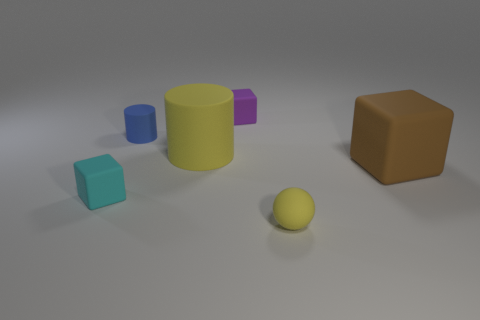Is the number of things that are to the left of the brown block greater than the number of tiny cyan metal balls?
Ensure brevity in your answer.  Yes. How many tiny things are either yellow matte cylinders or green rubber spheres?
Your response must be concise. 0. What number of big brown matte things are the same shape as the tiny yellow object?
Make the answer very short. 0. There is a cube to the right of the yellow matte sphere; what size is it?
Give a very brief answer. Large. What number of purple things are either tiny cylinders or spheres?
Provide a succinct answer. 0. What material is the other big thing that is the same shape as the blue matte object?
Your response must be concise. Rubber. Is the number of brown cubes to the left of the big matte cylinder the same as the number of small gray metallic cylinders?
Your answer should be very brief. Yes. There is a thing that is both behind the tiny cyan matte block and right of the purple matte cube; what size is it?
Provide a short and direct response. Large. Are there any other things that have the same color as the small matte cylinder?
Ensure brevity in your answer.  No. What size is the yellow matte thing that is in front of the yellow object that is behind the tiny yellow matte ball?
Your response must be concise. Small. 